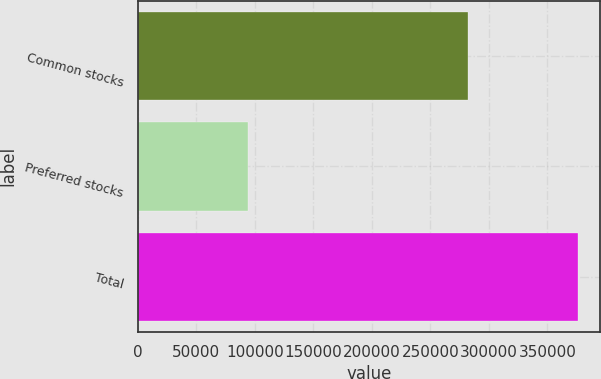Convert chart to OTSL. <chart><loc_0><loc_0><loc_500><loc_500><bar_chart><fcel>Common stocks<fcel>Preferred stocks<fcel>Total<nl><fcel>282066<fcel>93956<fcel>376022<nl></chart> 